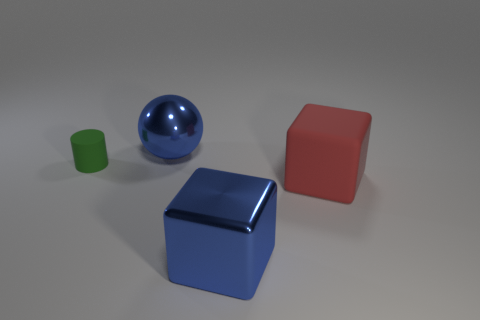Subtract all red blocks. How many blocks are left? 1 Subtract 0 red cylinders. How many objects are left? 4 Subtract all cylinders. How many objects are left? 3 Subtract 2 cubes. How many cubes are left? 0 Subtract all red balls. Subtract all cyan cylinders. How many balls are left? 1 Subtract all red spheres. How many green blocks are left? 0 Subtract all big purple rubber objects. Subtract all blue cubes. How many objects are left? 3 Add 2 blue things. How many blue things are left? 4 Add 3 yellow matte objects. How many yellow matte objects exist? 3 Add 2 purple things. How many objects exist? 6 